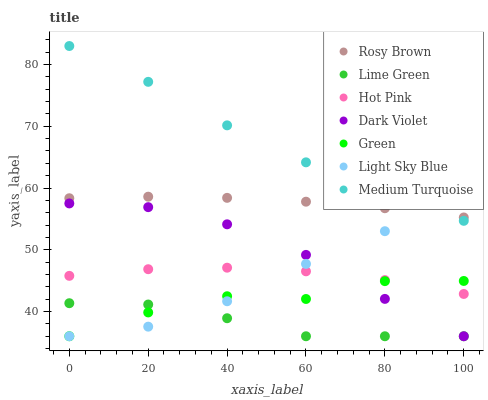Does Lime Green have the minimum area under the curve?
Answer yes or no. Yes. Does Medium Turquoise have the maximum area under the curve?
Answer yes or no. Yes. Does Rosy Brown have the minimum area under the curve?
Answer yes or no. No. Does Rosy Brown have the maximum area under the curve?
Answer yes or no. No. Is Rosy Brown the smoothest?
Answer yes or no. Yes. Is Green the roughest?
Answer yes or no. Yes. Is Dark Violet the smoothest?
Answer yes or no. No. Is Dark Violet the roughest?
Answer yes or no. No. Does Dark Violet have the lowest value?
Answer yes or no. Yes. Does Rosy Brown have the lowest value?
Answer yes or no. No. Does Medium Turquoise have the highest value?
Answer yes or no. Yes. Does Rosy Brown have the highest value?
Answer yes or no. No. Is Green less than Rosy Brown?
Answer yes or no. Yes. Is Medium Turquoise greater than Hot Pink?
Answer yes or no. Yes. Does Dark Violet intersect Light Sky Blue?
Answer yes or no. Yes. Is Dark Violet less than Light Sky Blue?
Answer yes or no. No. Is Dark Violet greater than Light Sky Blue?
Answer yes or no. No. Does Green intersect Rosy Brown?
Answer yes or no. No. 